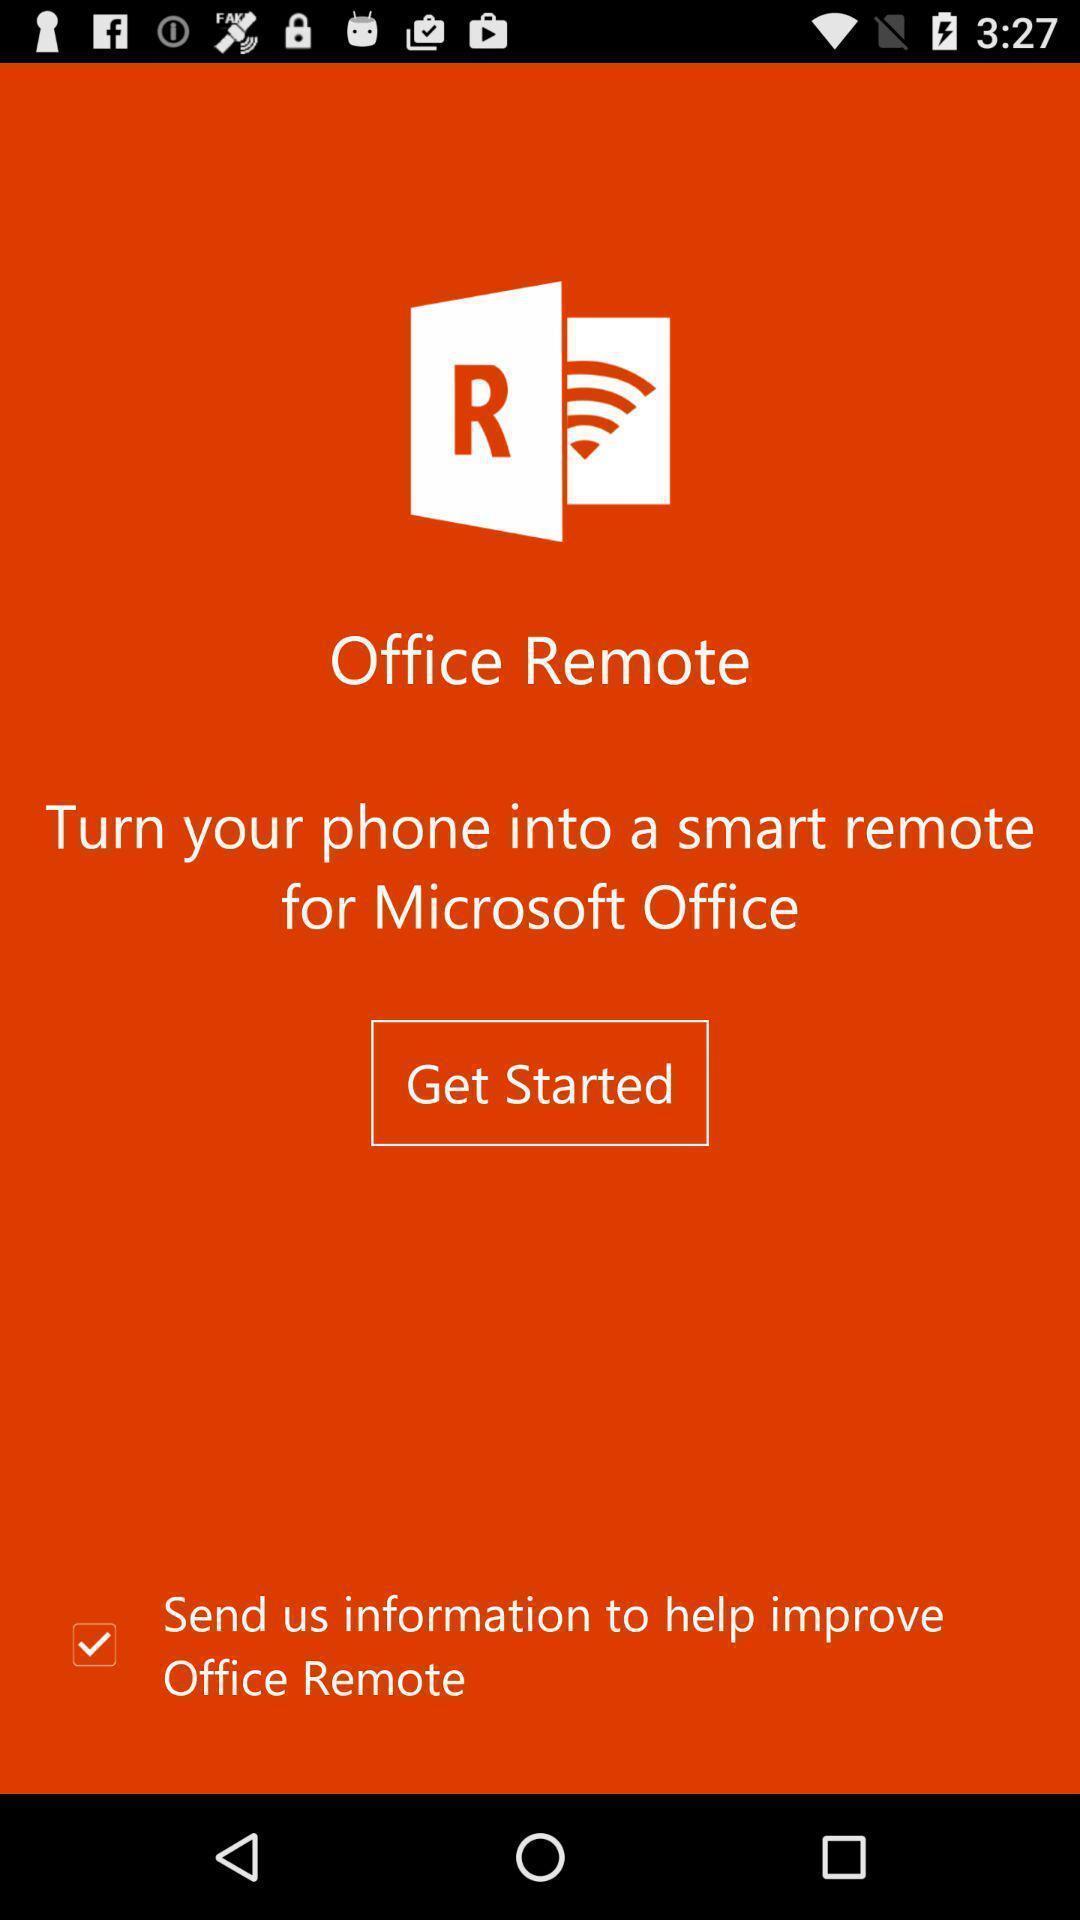Tell me about the visual elements in this screen capture. Welcome page of a remote application. 